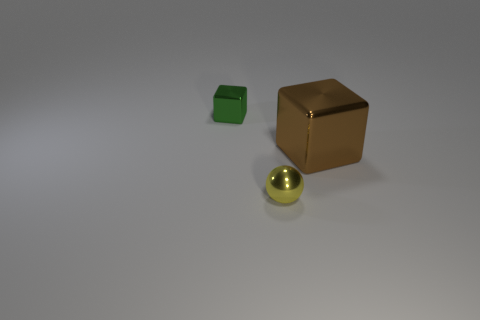Could you describe the lighting and shadows seen in the image? The image presents a soft, diffused lighting situation with gentle shadows behind the objects, suggesting an indirect light source that doesn't create harsh contrasts. This type of lighting gives the scene a calm and uniform appearance. 